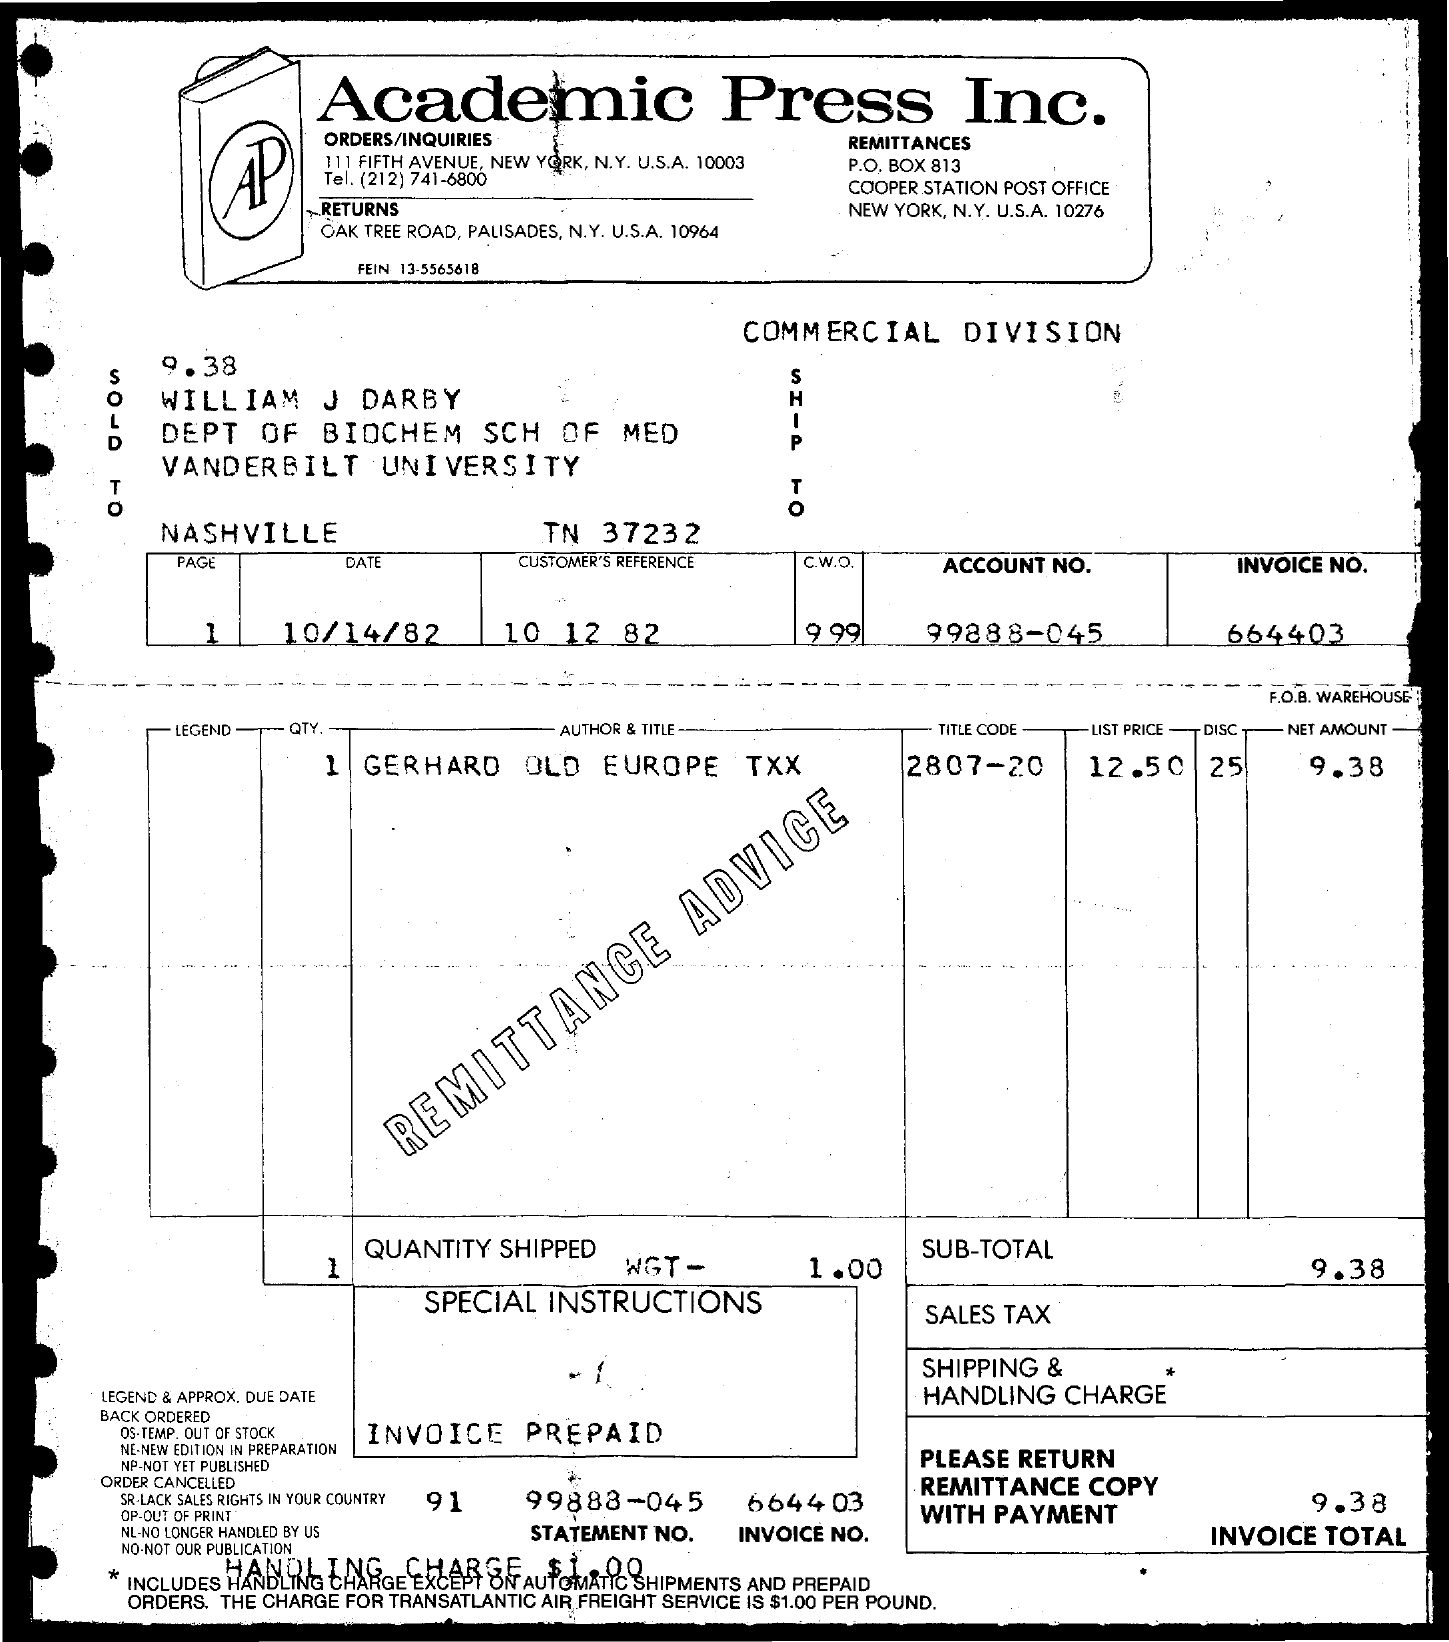Give some essential details in this illustration. The list price of Gerhard Old Europe TXX is $12.50. The net amount of Gerhard Old Europe TXX is 9.38... The invoice number is 664403... What is the title code of Gerhard Old Europe TXX? I am unable to access it as there are too many numbers in the code and I am unable to identify the specific code I am looking for. 